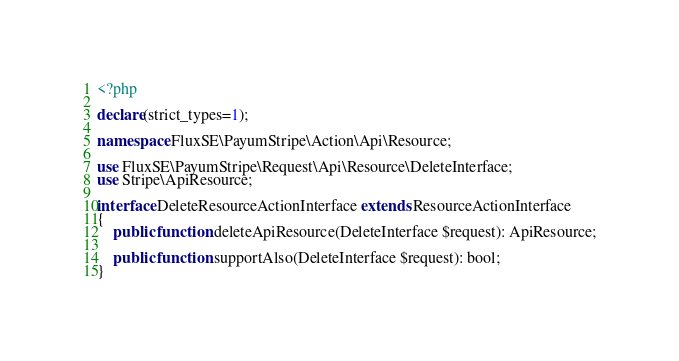Convert code to text. <code><loc_0><loc_0><loc_500><loc_500><_PHP_><?php

declare(strict_types=1);

namespace FluxSE\PayumStripe\Action\Api\Resource;

use FluxSE\PayumStripe\Request\Api\Resource\DeleteInterface;
use Stripe\ApiResource;

interface DeleteResourceActionInterface extends ResourceActionInterface
{
    public function deleteApiResource(DeleteInterface $request): ApiResource;

    public function supportAlso(DeleteInterface $request): bool;
}
</code> 